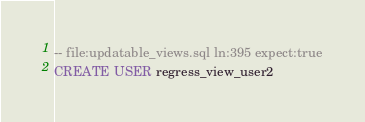<code> <loc_0><loc_0><loc_500><loc_500><_SQL_>-- file:updatable_views.sql ln:395 expect:true
CREATE USER regress_view_user2
</code> 